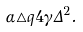<formula> <loc_0><loc_0><loc_500><loc_500>\alpha \triangle q 4 \gamma \Delta ^ { 2 } .</formula> 